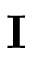<formula> <loc_0><loc_0><loc_500><loc_500>I</formula> 